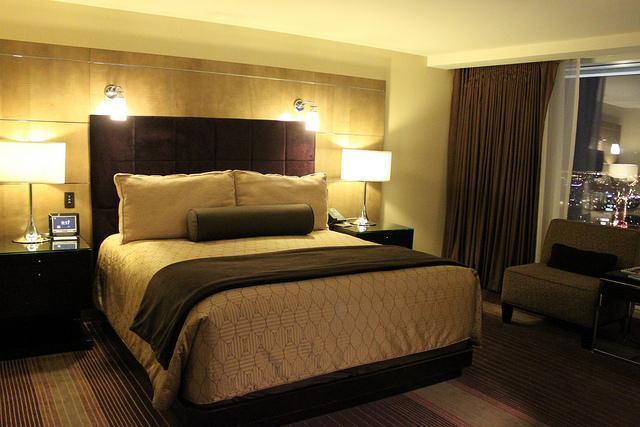How many lamps are there?
Give a very brief answer. 4. How many pillows are on the bed?
Give a very brief answer. 3. How many chairs are in the picture?
Give a very brief answer. 1. 